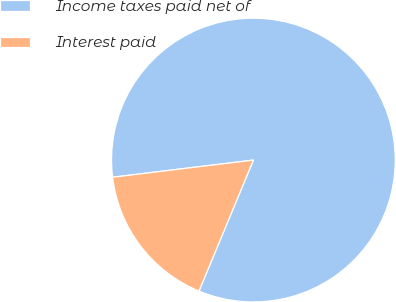Convert chart. <chart><loc_0><loc_0><loc_500><loc_500><pie_chart><fcel>Income taxes paid net of<fcel>Interest paid<nl><fcel>83.2%<fcel>16.8%<nl></chart> 